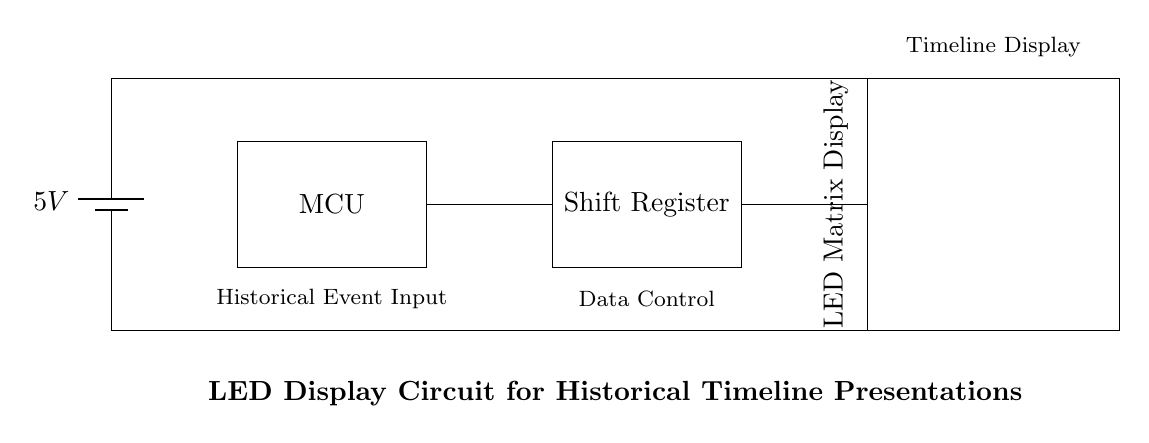What is the voltage of this circuit? The voltage is 5V, which is indicated on the battery symbol in the circuit diagram as the power supply for the circuit.
Answer: 5V What component is represented by the rectangle labeled "MCU"? The rectangle labeled "MCU" stands for Microcontroller, as mentioned in the diagram, indicating it is a key component that controls the circuit operations.
Answer: Microcontroller How many main components are there in the circuit? There are three main components: a microcontroller, a shift register, and an LED matrix display, which are sequentially arranged in the circuit.
Answer: Three What is the function of the shift register in this circuit? The shift register is used for data control, which means it manages the input data flow to convert it into a format suitable for LED display utilization.
Answer: Data Control What does the LED matrix display signify in this circuit? The LED matrix display is used to visually display the historical timeline information inputted into the system, translating digital signals into visual output.
Answer: Timeline Display What are the key connections made in the circuit? The key connections are between the microcontroller and the shift register, and between the shift register and the LED matrix display, which facilitate data flow between these components.
Answer: Connections between components What is the role of the power supply in this circuit? The power supply provides the necessary voltage (5V) required for all the components to function properly, ensuring they receive adequate energy for operation.
Answer: Power Supply 